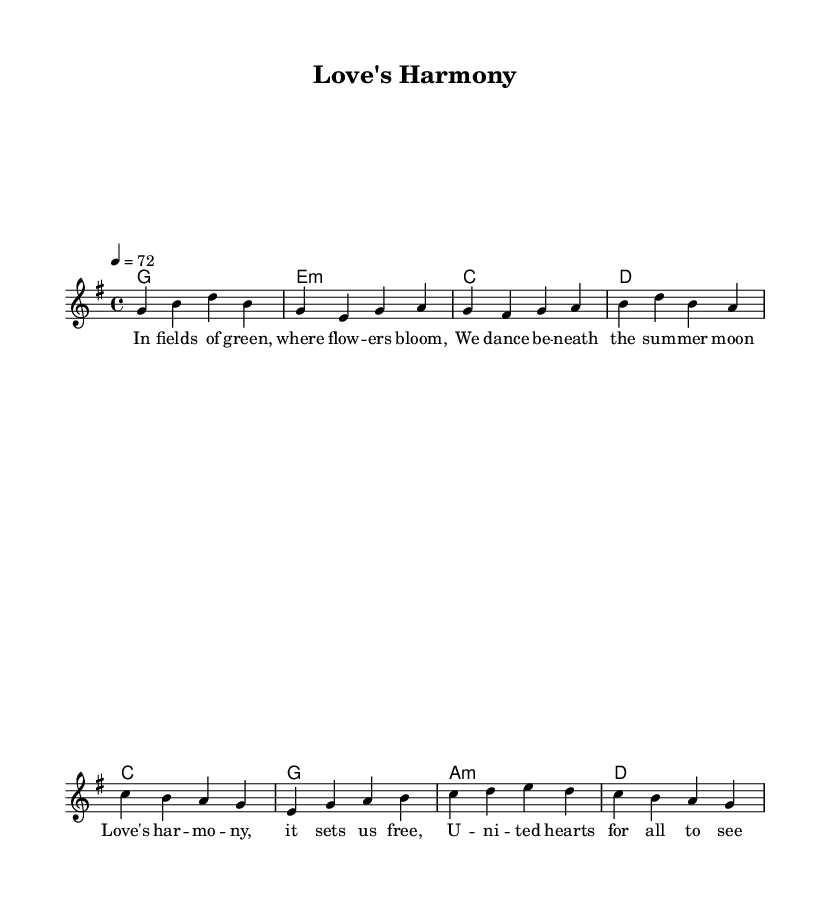What is the key signature of this music? The key signature indicates G major, which has one sharp (F#). This can be identified by looking at the beginning of the staff where the sharps are notated.
Answer: G major What is the time signature of the piece? The time signature is 4/4, as seen at the beginning of the score, which indicates there are four beats in each measure.
Answer: 4/4 What is the tempo marking for this piece? The tempo marking is set at 72 beats per minute, which can be found above the staff next to the tempo indication "4 = 72".
Answer: 72 How many measures are in the verse? There are four measures in the verse section, as counted from the melody portion of the score specifically focusing on the notes in the verse.
Answer: 4 What chords are used in the chorus? The chords for the chorus include C major, G major, A minor, and D major, which can be identified in the chord section under the designated "Chorus" label.
Answer: C, G, A minor, D What theme does the song explore? The song explores themes of love and unity, as indicated by the lyrics in the verse and chorus which speak about dancing in fields and united hearts.
Answer: Love and unity Why is this song classified as a country rock ballad? This song is classified as a country rock ballad due to its acoustic-driven melody, lyrical themes of love and harmony, and typical chord progressions found in country rock music.
Answer: Acoustic-driven country rock 